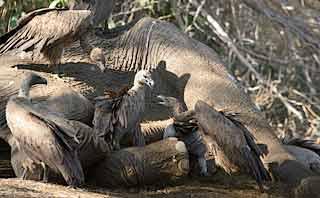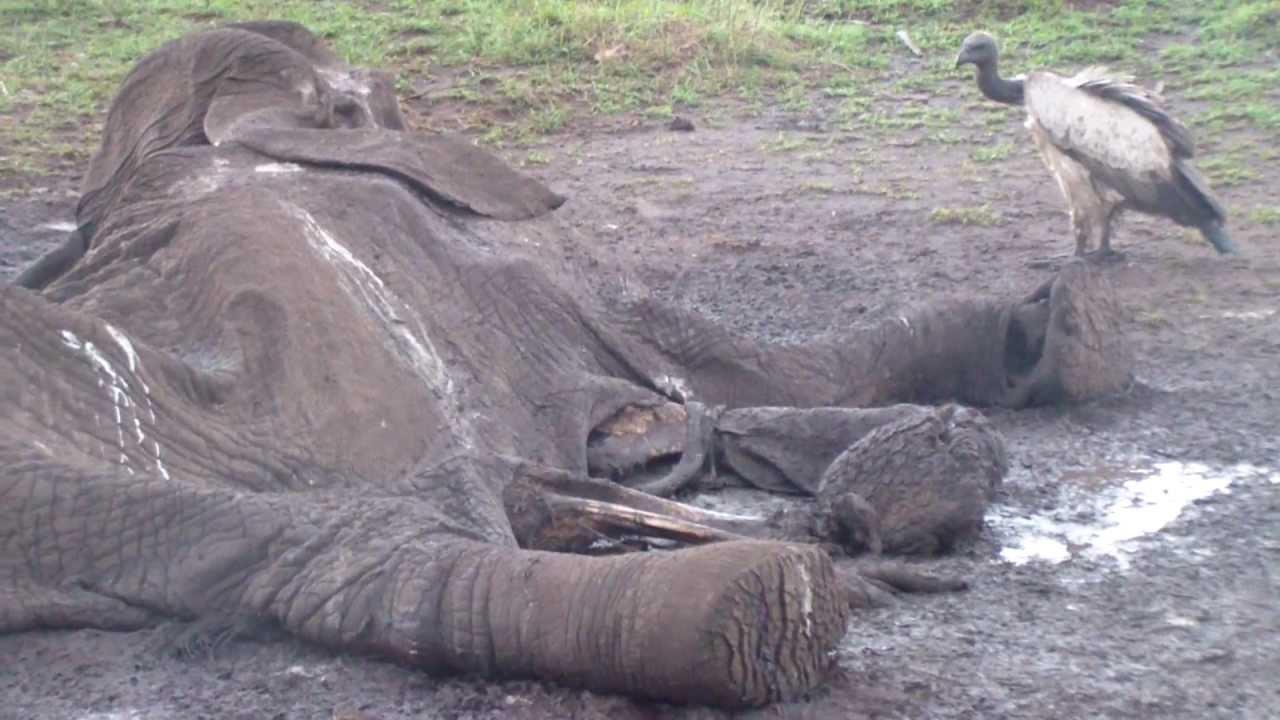The first image is the image on the left, the second image is the image on the right. For the images shown, is this caption "there is a hyena in the image on the right." true? Answer yes or no. No. The first image is the image on the left, the second image is the image on the right. For the images displayed, is the sentence "In the right image, at least one hyena is present along with vultures." factually correct? Answer yes or no. No. 